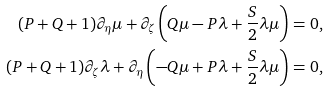Convert formula to latex. <formula><loc_0><loc_0><loc_500><loc_500>( P + Q + 1 ) \partial _ { \eta } \mu + \partial _ { \zeta } \left ( Q \mu - P \lambda + \frac { S } { 2 } \lambda \mu \right ) = 0 , \\ ( P + Q + 1 ) \partial _ { \zeta } \lambda + \partial _ { \eta } \left ( - Q \mu + P \lambda + \frac { S } { 2 } \lambda \mu \right ) = 0 ,</formula> 